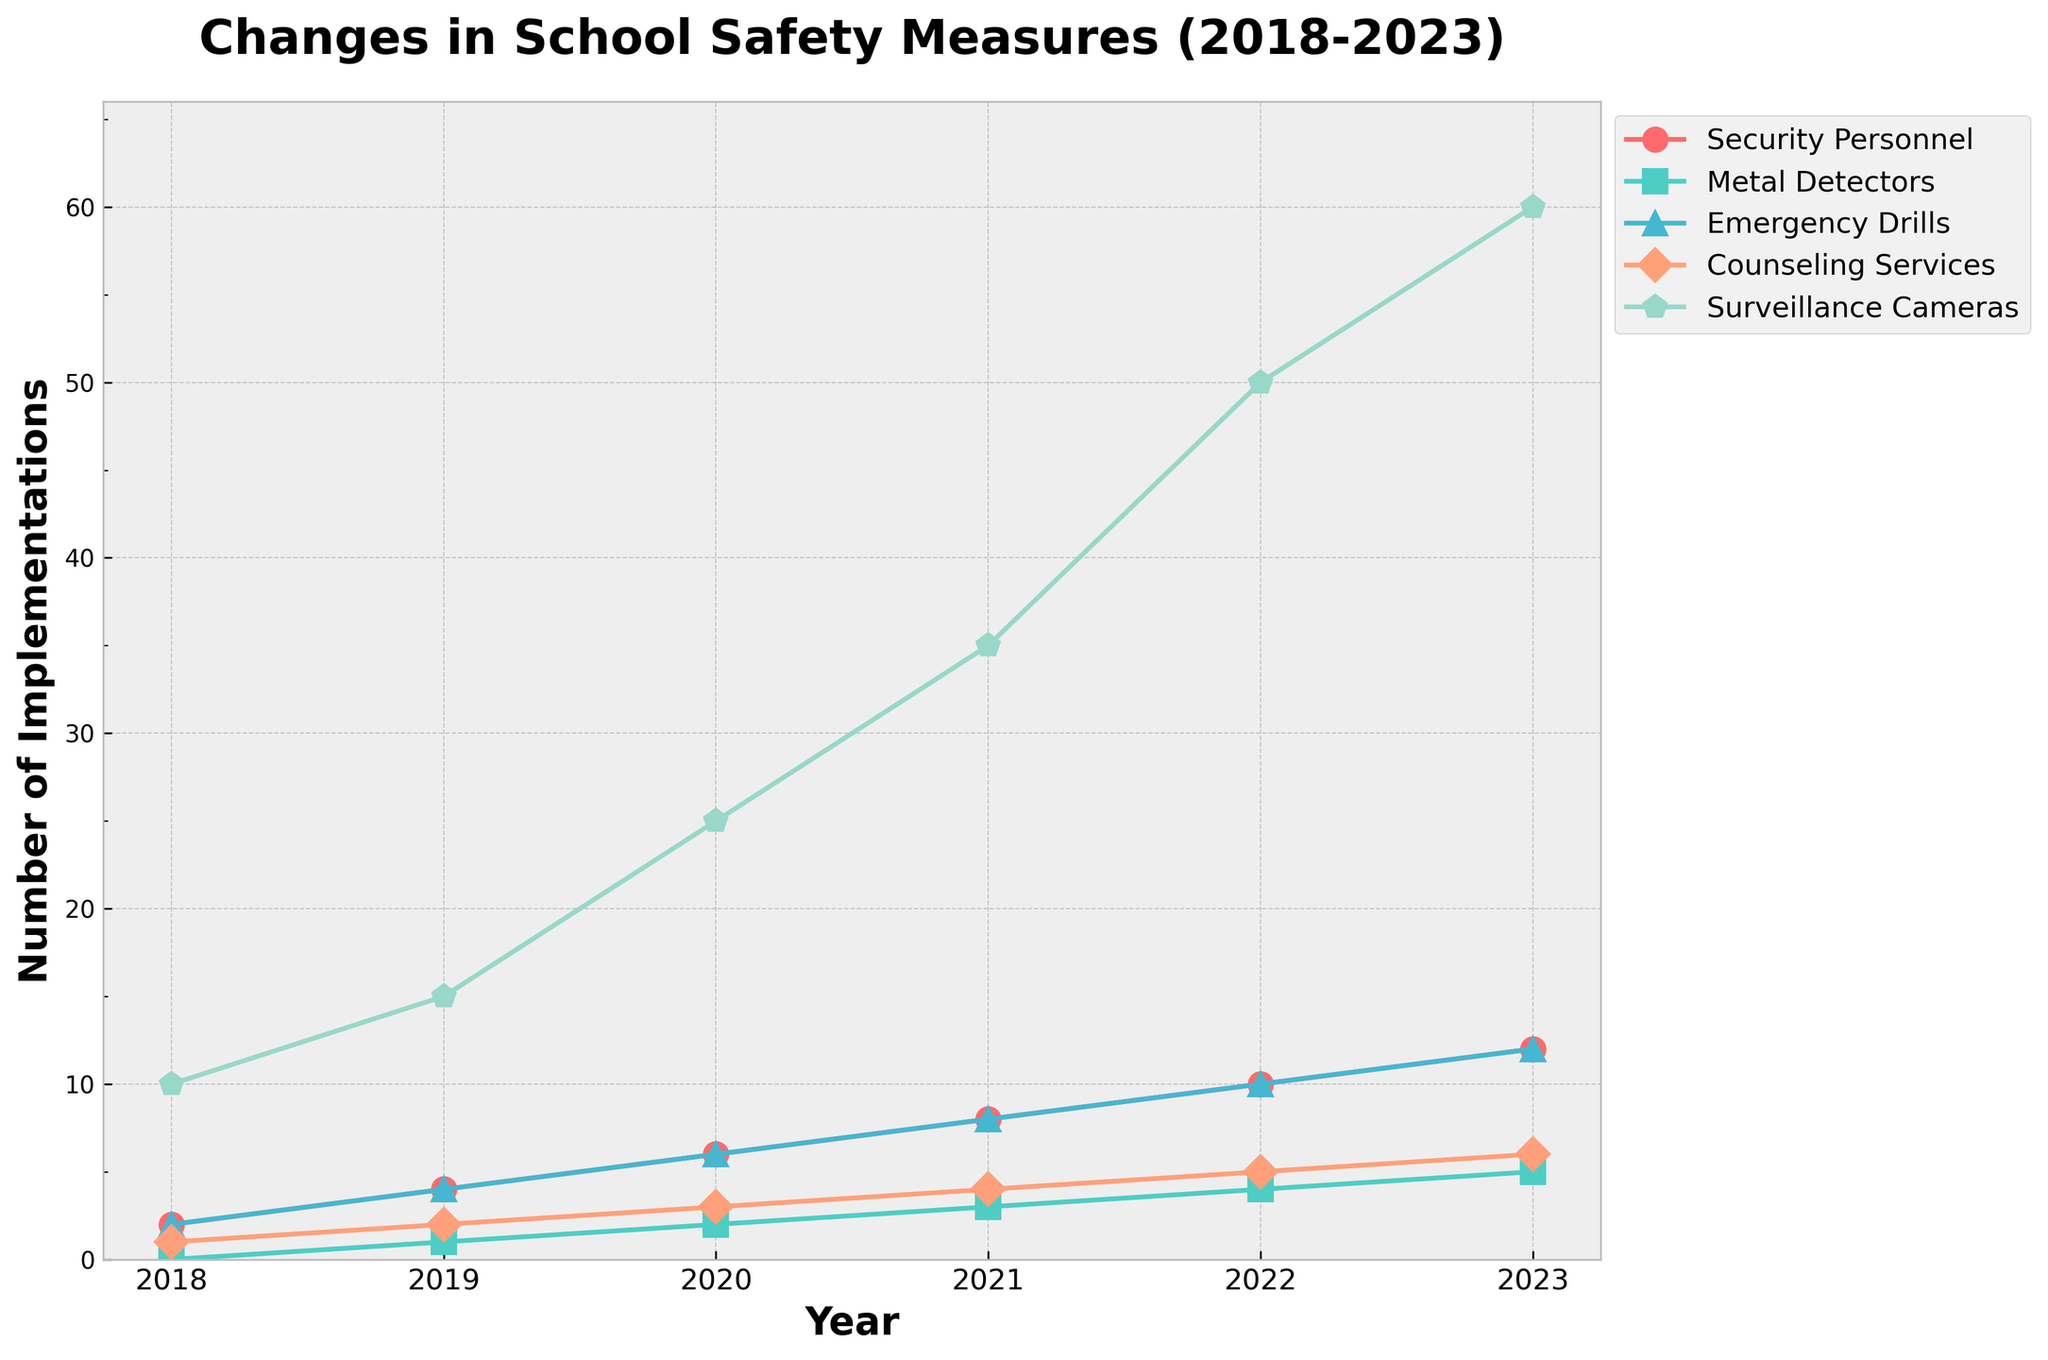What is the trend of Surveillance Cameras installations from 2018 to 2023? The line representing Surveillance Cameras is consistently increasing across the years from 2018 to 2023. This can be seen as the points for Surveillance Cameras rise steadily each year.
Answer: Increasing By how many units did the number of Security Personnel increase from 2018 to 2023? The number of Security Personnel in 2018 was 2 and in 2023 it is 12. The increase is 12 - 2 = 10 units.
Answer: 10 Which safety measure had the highest number of implementations in 2023? In 2023, Surveillance Cameras had the highest number of implementations at 60, as shown by the highest point on the graph for that year.
Answer: Surveillance Cameras Between which two consecutive years was the increase in Counseling Services the greatest? Comparing changes: from 2018 to 2019, Counseling Services increased by 1; from 2019 to 2020 by 1; from 2020 to 2021 by 1; from 2021 to 2022 by 1; and from 2022 to 2023 by 1. All have equal increases.
Answer: All equal What is the average number of Emergency Drills implemented from 2018 to 2023? To find the average: add the values (2 + 4 + 6 + 8 + 10 + 12 = 42), then divide by the number of years (2023 - 2018 + 1 = 6): 42 / 6 = 7.
Answer: 7 In which year do Metal Detectors surpass 2 implementations? By looking at the Metal Detectors line, we see that it surpasses 2 implementations in 2021, as the values before 2021 are 0, 1, 2, and 2021 has a value of 3.
Answer: 2021 How many more Surveillance Cameras were there in 2023 compared to 2020? The number of Surveillance Cameras in 2023 is 60, and in 2020 it was 25. The difference is 60 - 25 = 35.
Answer: 35 Calculate the total number of Security Personnel added from 2018 to 2022. The increases are: from 2018 to 2019 is 2 to 4 = 2; from 2019 to 2020 is 4 to 6 = 2; from 2020 to 2021 is 6 to 8 = 2; from 2021 to 2022 is 8 to 10 = 2. Summing these: 2 + 2 + 2 + 2 = 8.
Answer: 8 Which measure had the smallest increase from 2021 to 2022? Comparing increases: Security Personnel (8 to 10, increase of 2), Metal Detectors (3 to 4, increase of 1), Emergency Drills (8 to 10, increase of 2), Counseling Services (4 to 5, increase of 1), Surveillance Cameras (35 to 50, increase of 15). Both Metal Detectors and Counseling Services have the smallest increase of 1 each.
Answer: Metal Detectors and Counseling Services 